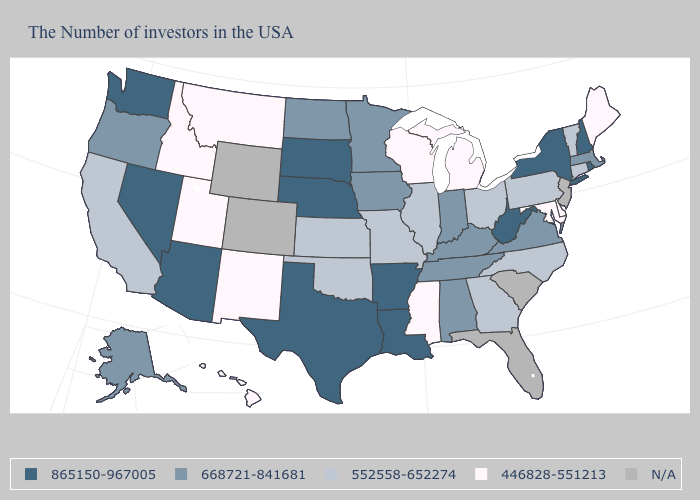Name the states that have a value in the range N/A?
Short answer required. New Jersey, South Carolina, Florida, Wyoming, Colorado. Which states have the lowest value in the Northeast?
Keep it brief. Maine. What is the lowest value in the USA?
Give a very brief answer. 446828-551213. Name the states that have a value in the range 446828-551213?
Answer briefly. Maine, Delaware, Maryland, Michigan, Wisconsin, Mississippi, New Mexico, Utah, Montana, Idaho, Hawaii. What is the value of Florida?
Concise answer only. N/A. What is the value of Indiana?
Keep it brief. 668721-841681. Which states have the lowest value in the Northeast?
Quick response, please. Maine. Name the states that have a value in the range 552558-652274?
Quick response, please. Vermont, Connecticut, Pennsylvania, North Carolina, Ohio, Georgia, Illinois, Missouri, Kansas, Oklahoma, California. Name the states that have a value in the range 668721-841681?
Answer briefly. Massachusetts, Virginia, Kentucky, Indiana, Alabama, Tennessee, Minnesota, Iowa, North Dakota, Oregon, Alaska. Among the states that border South Dakota , does Nebraska have the highest value?
Short answer required. Yes. Name the states that have a value in the range 668721-841681?
Give a very brief answer. Massachusetts, Virginia, Kentucky, Indiana, Alabama, Tennessee, Minnesota, Iowa, North Dakota, Oregon, Alaska. What is the value of Idaho?
Quick response, please. 446828-551213. What is the value of Arizona?
Concise answer only. 865150-967005. Among the states that border North Carolina , does Georgia have the lowest value?
Concise answer only. Yes. Which states have the lowest value in the MidWest?
Be succinct. Michigan, Wisconsin. 